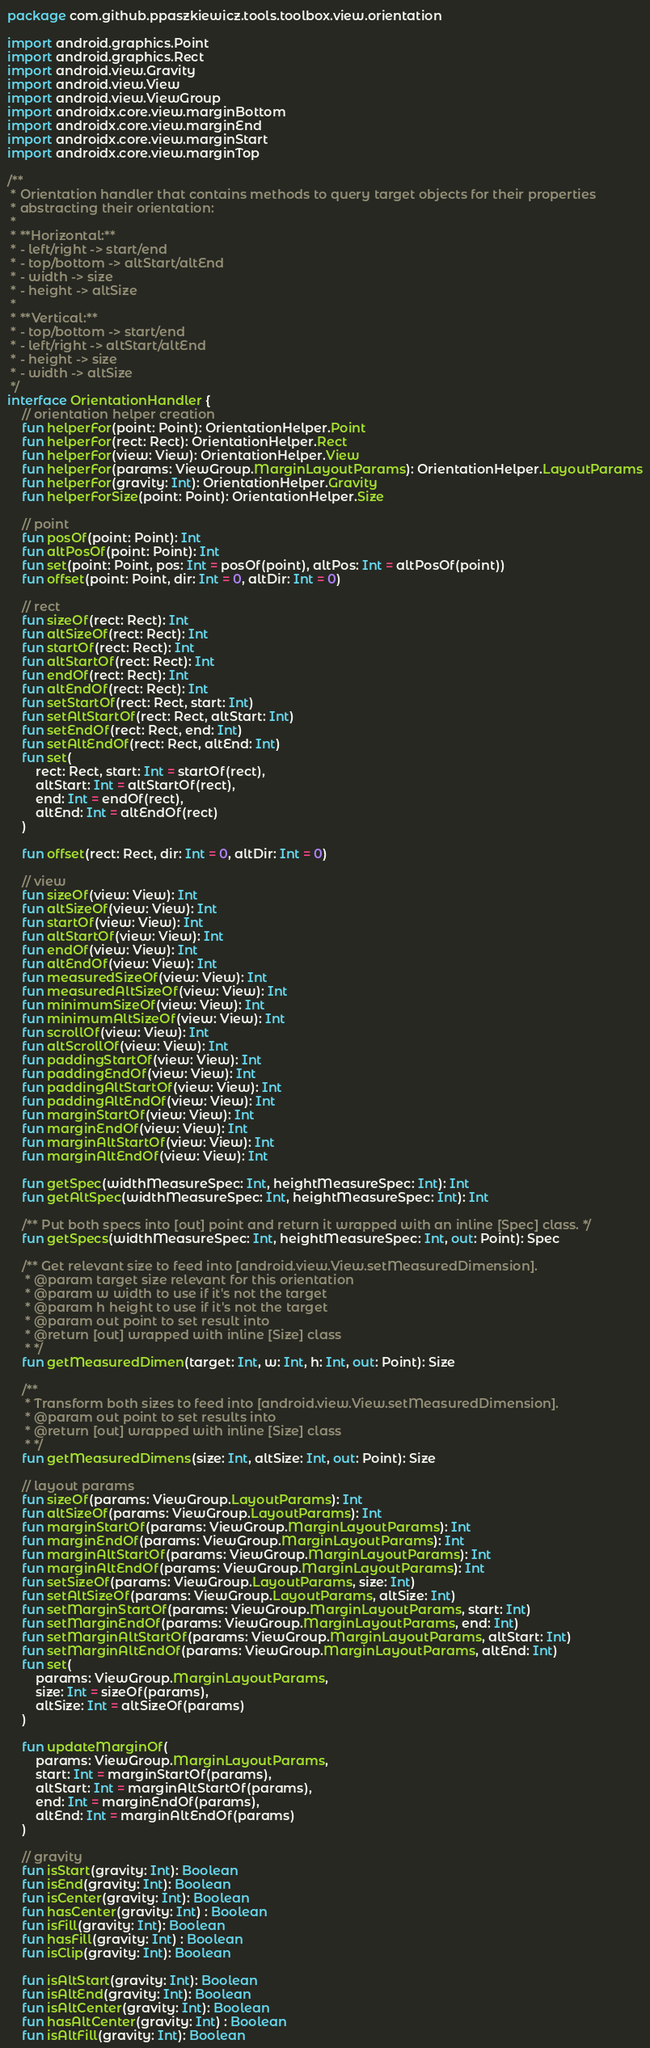Convert code to text. <code><loc_0><loc_0><loc_500><loc_500><_Kotlin_>package com.github.ppaszkiewicz.tools.toolbox.view.orientation

import android.graphics.Point
import android.graphics.Rect
import android.view.Gravity
import android.view.View
import android.view.ViewGroup
import androidx.core.view.marginBottom
import androidx.core.view.marginEnd
import androidx.core.view.marginStart
import androidx.core.view.marginTop

/**
 * Orientation handler that contains methods to query target objects for their properties
 * abstracting their orientation:
 *
 * **Horizontal:**
 * - left/right -> start/end
 * - top/bottom -> altStart/altEnd
 * - width -> size
 * - height -> altSize
 *
 * **Vertical:**
 * - top/bottom -> start/end
 * - left/right -> altStart/altEnd
 * - height -> size
 * - width -> altSize
 */
interface OrientationHandler {
    // orientation helper creation
    fun helperFor(point: Point): OrientationHelper.Point
    fun helperFor(rect: Rect): OrientationHelper.Rect
    fun helperFor(view: View): OrientationHelper.View
    fun helperFor(params: ViewGroup.MarginLayoutParams): OrientationHelper.LayoutParams
    fun helperFor(gravity: Int): OrientationHelper.Gravity
    fun helperForSize(point: Point): OrientationHelper.Size

    // point
    fun posOf(point: Point): Int
    fun altPosOf(point: Point): Int
    fun set(point: Point, pos: Int = posOf(point), altPos: Int = altPosOf(point))
    fun offset(point: Point, dir: Int = 0, altDir: Int = 0)

    // rect
    fun sizeOf(rect: Rect): Int
    fun altSizeOf(rect: Rect): Int
    fun startOf(rect: Rect): Int
    fun altStartOf(rect: Rect): Int
    fun endOf(rect: Rect): Int
    fun altEndOf(rect: Rect): Int
    fun setStartOf(rect: Rect, start: Int)
    fun setAltStartOf(rect: Rect, altStart: Int)
    fun setEndOf(rect: Rect, end: Int)
    fun setAltEndOf(rect: Rect, altEnd: Int)
    fun set(
        rect: Rect, start: Int = startOf(rect),
        altStart: Int = altStartOf(rect),
        end: Int = endOf(rect),
        altEnd: Int = altEndOf(rect)
    )

    fun offset(rect: Rect, dir: Int = 0, altDir: Int = 0)

    // view
    fun sizeOf(view: View): Int
    fun altSizeOf(view: View): Int
    fun startOf(view: View): Int
    fun altStartOf(view: View): Int
    fun endOf(view: View): Int
    fun altEndOf(view: View): Int
    fun measuredSizeOf(view: View): Int
    fun measuredAltSizeOf(view: View): Int
    fun minimumSizeOf(view: View): Int
    fun minimumAltSizeOf(view: View): Int
    fun scrollOf(view: View): Int
    fun altScrollOf(view: View): Int
    fun paddingStartOf(view: View): Int
    fun paddingEndOf(view: View): Int
    fun paddingAltStartOf(view: View): Int
    fun paddingAltEndOf(view: View): Int
    fun marginStartOf(view: View): Int
    fun marginEndOf(view: View): Int
    fun marginAltStartOf(view: View): Int
    fun marginAltEndOf(view: View): Int

    fun getSpec(widthMeasureSpec: Int, heightMeasureSpec: Int): Int
    fun getAltSpec(widthMeasureSpec: Int, heightMeasureSpec: Int): Int

    /** Put both specs into [out] point and return it wrapped with an inline [Spec] class. */
    fun getSpecs(widthMeasureSpec: Int, heightMeasureSpec: Int, out: Point): Spec

    /** Get relevant size to feed into [android.view.View.setMeasuredDimension].
     * @param target size relevant for this orientation
     * @param w width to use if it's not the target
     * @param h height to use if it's not the target
     * @param out point to set result into
     * @return [out] wrapped with inline [Size] class
     * */
    fun getMeasuredDimen(target: Int, w: Int, h: Int, out: Point): Size

    /**
     * Transform both sizes to feed into [android.view.View.setMeasuredDimension].
     * @param out point to set results into
     * @return [out] wrapped with inline [Size] class
     * */
    fun getMeasuredDimens(size: Int, altSize: Int, out: Point): Size

    // layout params
    fun sizeOf(params: ViewGroup.LayoutParams): Int
    fun altSizeOf(params: ViewGroup.LayoutParams): Int
    fun marginStartOf(params: ViewGroup.MarginLayoutParams): Int
    fun marginEndOf(params: ViewGroup.MarginLayoutParams): Int
    fun marginAltStartOf(params: ViewGroup.MarginLayoutParams): Int
    fun marginAltEndOf(params: ViewGroup.MarginLayoutParams): Int
    fun setSizeOf(params: ViewGroup.LayoutParams, size: Int)
    fun setAltSizeOf(params: ViewGroup.LayoutParams, altSize: Int)
    fun setMarginStartOf(params: ViewGroup.MarginLayoutParams, start: Int)
    fun setMarginEndOf(params: ViewGroup.MarginLayoutParams, end: Int)
    fun setMarginAltStartOf(params: ViewGroup.MarginLayoutParams, altStart: Int)
    fun setMarginAltEndOf(params: ViewGroup.MarginLayoutParams, altEnd: Int)
    fun set(
        params: ViewGroup.MarginLayoutParams,
        size: Int = sizeOf(params),
        altSize: Int = altSizeOf(params)
    )

    fun updateMarginOf(
        params: ViewGroup.MarginLayoutParams,
        start: Int = marginStartOf(params),
        altStart: Int = marginAltStartOf(params),
        end: Int = marginEndOf(params),
        altEnd: Int = marginAltEndOf(params)
    )

    // gravity
    fun isStart(gravity: Int): Boolean
    fun isEnd(gravity: Int): Boolean
    fun isCenter(gravity: Int): Boolean
    fun hasCenter(gravity: Int) : Boolean
    fun isFill(gravity: Int): Boolean
    fun hasFill(gravity: Int) : Boolean
    fun isClip(gravity: Int): Boolean

    fun isAltStart(gravity: Int): Boolean
    fun isAltEnd(gravity: Int): Boolean
    fun isAltCenter(gravity: Int): Boolean
    fun hasAltCenter(gravity: Int) : Boolean
    fun isAltFill(gravity: Int): Boolean</code> 